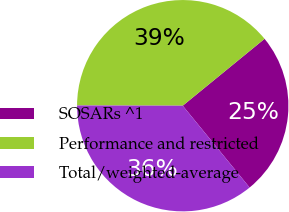<chart> <loc_0><loc_0><loc_500><loc_500><pie_chart><fcel>SOSARs ^1<fcel>Performance and restricted<fcel>Total/weighted-average<nl><fcel>25.0%<fcel>39.06%<fcel>35.94%<nl></chart> 